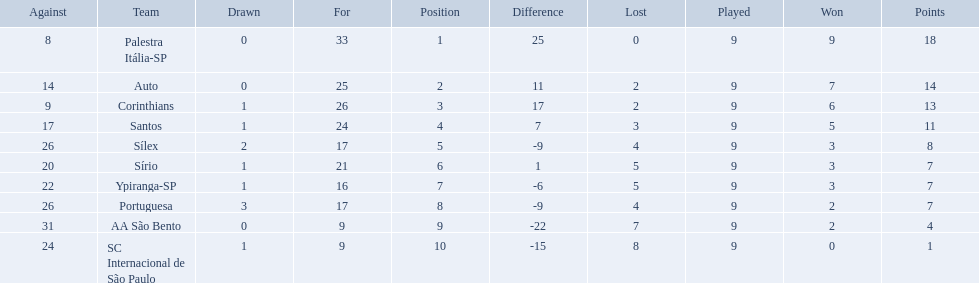What were the top three amounts of games won for 1926 in brazilian football season? 9, 7, 6. What were the top amount of games won for 1926 in brazilian football season? 9. What team won the top amount of games Palestra Itália-SP. 